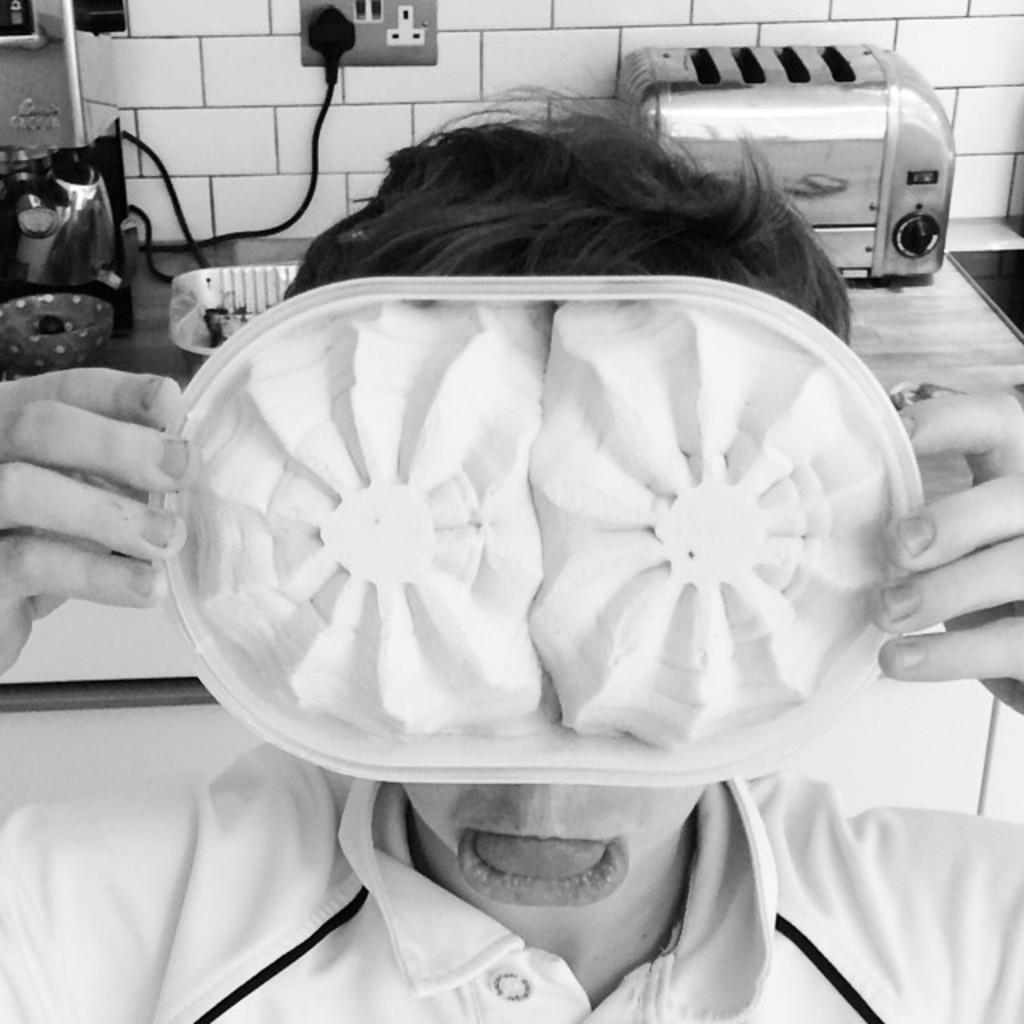What is the person in the image holding? The person is holding a plate in the image. Where is the person located in relation to the table? The person is near a table in the image. What can be seen on the table? There is a tray, a bowl, a heater, and other objects on the table. What is the background of the image? The background of the image includes a white color tiles wall. How does the person in the image contribute to the development of the area? There is no information in the image about the person's contribution to the development of the area. What type of fork is visible on the table in the image? There is no fork visible on the table in the image. 